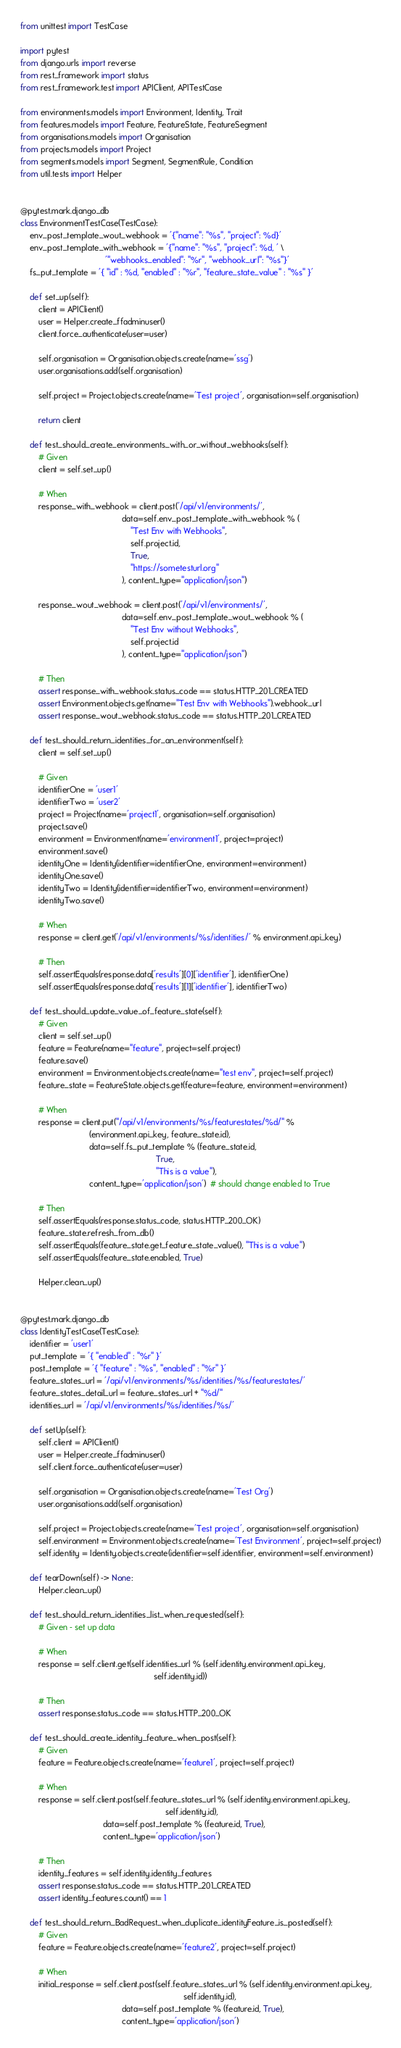Convert code to text. <code><loc_0><loc_0><loc_500><loc_500><_Python_>from unittest import TestCase

import pytest
from django.urls import reverse
from rest_framework import status
from rest_framework.test import APIClient, APITestCase

from environments.models import Environment, Identity, Trait
from features.models import Feature, FeatureState, FeatureSegment
from organisations.models import Organisation
from projects.models import Project
from segments.models import Segment, SegmentRule, Condition
from util.tests import Helper


@pytest.mark.django_db
class EnvironmentTestCase(TestCase):
    env_post_template_wout_webhook = '{"name": "%s", "project": %d}'
    env_post_template_with_webhook = '{"name": "%s", "project": %d, ' \
                                     '"webhooks_enabled": "%r", "webhook_url": "%s"}'
    fs_put_template = '{ "id" : %d, "enabled" : "%r", "feature_state_value" : "%s" }'

    def set_up(self):
        client = APIClient()
        user = Helper.create_ffadminuser()
        client.force_authenticate(user=user)

        self.organisation = Organisation.objects.create(name='ssg')
        user.organisations.add(self.organisation)

        self.project = Project.objects.create(name='Test project', organisation=self.organisation)

        return client

    def test_should_create_environments_with_or_without_webhooks(self):
        # Given
        client = self.set_up()

        # When
        response_with_webhook = client.post('/api/v1/environments/',
                                            data=self.env_post_template_with_webhook % (
                                                "Test Env with Webhooks",
                                                self.project.id,
                                                True,
                                                "https://sometesturl.org"
                                            ), content_type="application/json")

        response_wout_webhook = client.post('/api/v1/environments/',
                                            data=self.env_post_template_wout_webhook % (
                                                "Test Env without Webhooks",
                                                self.project.id
                                            ), content_type="application/json")

        # Then
        assert response_with_webhook.status_code == status.HTTP_201_CREATED
        assert Environment.objects.get(name="Test Env with Webhooks").webhook_url
        assert response_wout_webhook.status_code == status.HTTP_201_CREATED

    def test_should_return_identities_for_an_environment(self):
        client = self.set_up()

        # Given
        identifierOne = 'user1'
        identifierTwo = 'user2'
        project = Project(name='project1', organisation=self.organisation)
        project.save()
        environment = Environment(name='environment1', project=project)
        environment.save()
        identityOne = Identity(identifier=identifierOne, environment=environment)
        identityOne.save()
        identityTwo = Identity(identifier=identifierTwo, environment=environment)
        identityTwo.save()

        # When
        response = client.get('/api/v1/environments/%s/identities/' % environment.api_key)

        # Then
        self.assertEquals(response.data['results'][0]['identifier'], identifierOne)
        self.assertEquals(response.data['results'][1]['identifier'], identifierTwo)

    def test_should_update_value_of_feature_state(self):
        # Given
        client = self.set_up()
        feature = Feature(name="feature", project=self.project)
        feature.save()
        environment = Environment.objects.create(name="test env", project=self.project)
        feature_state = FeatureState.objects.get(feature=feature, environment=environment)

        # When
        response = client.put("/api/v1/environments/%s/featurestates/%d/" %
                              (environment.api_key, feature_state.id),
                              data=self.fs_put_template % (feature_state.id,
                                                           True,
                                                           "This is a value"),
                              content_type='application/json')  # should change enabled to True

        # Then
        self.assertEquals(response.status_code, status.HTTP_200_OK)
        feature_state.refresh_from_db()
        self.assertEquals(feature_state.get_feature_state_value(), "This is a value")
        self.assertEquals(feature_state.enabled, True)

        Helper.clean_up()


@pytest.mark.django_db
class IdentityTestCase(TestCase):
    identifier = 'user1'
    put_template = '{ "enabled" : "%r" }'
    post_template = '{ "feature" : "%s", "enabled" : "%r" }'
    feature_states_url = '/api/v1/environments/%s/identities/%s/featurestates/'
    feature_states_detail_url = feature_states_url + "%d/"
    identities_url = '/api/v1/environments/%s/identities/%s/'

    def setUp(self):
        self.client = APIClient()
        user = Helper.create_ffadminuser()
        self.client.force_authenticate(user=user)

        self.organisation = Organisation.objects.create(name='Test Org')
        user.organisations.add(self.organisation)

        self.project = Project.objects.create(name='Test project', organisation=self.organisation)
        self.environment = Environment.objects.create(name='Test Environment', project=self.project)
        self.identity = Identity.objects.create(identifier=self.identifier, environment=self.environment)

    def tearDown(self) -> None:
        Helper.clean_up()

    def test_should_return_identities_list_when_requested(self):
        # Given - set up data

        # When
        response = self.client.get(self.identities_url % (self.identity.environment.api_key,
                                                          self.identity.id))

        # Then
        assert response.status_code == status.HTTP_200_OK

    def test_should_create_identity_feature_when_post(self):
        # Given
        feature = Feature.objects.create(name='feature1', project=self.project)

        # When
        response = self.client.post(self.feature_states_url % (self.identity.environment.api_key,
                                                               self.identity.id),
                                    data=self.post_template % (feature.id, True),
                                    content_type='application/json')

        # Then
        identity_features = self.identity.identity_features
        assert response.status_code == status.HTTP_201_CREATED
        assert identity_features.count() == 1

    def test_should_return_BadRequest_when_duplicate_identityFeature_is_posted(self):
        # Given
        feature = Feature.objects.create(name='feature2', project=self.project)

        # When
        initial_response = self.client.post(self.feature_states_url % (self.identity.environment.api_key,
                                                                       self.identity.id),
                                            data=self.post_template % (feature.id, True),
                                            content_type='application/json')</code> 